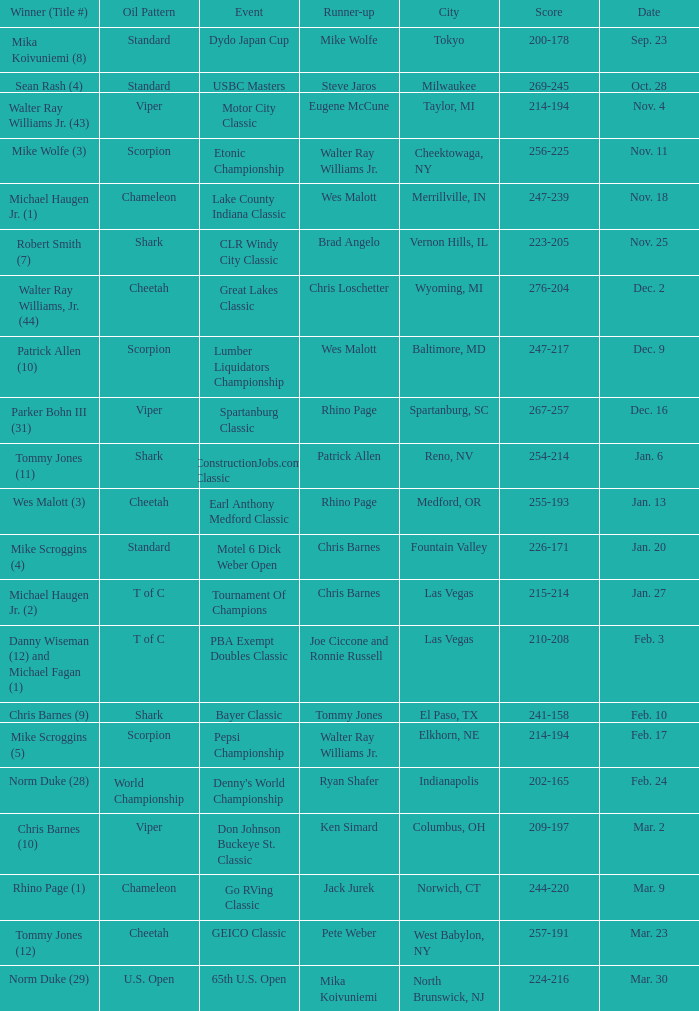Name the Event which has a Score of 209-197? Don Johnson Buckeye St. Classic. 